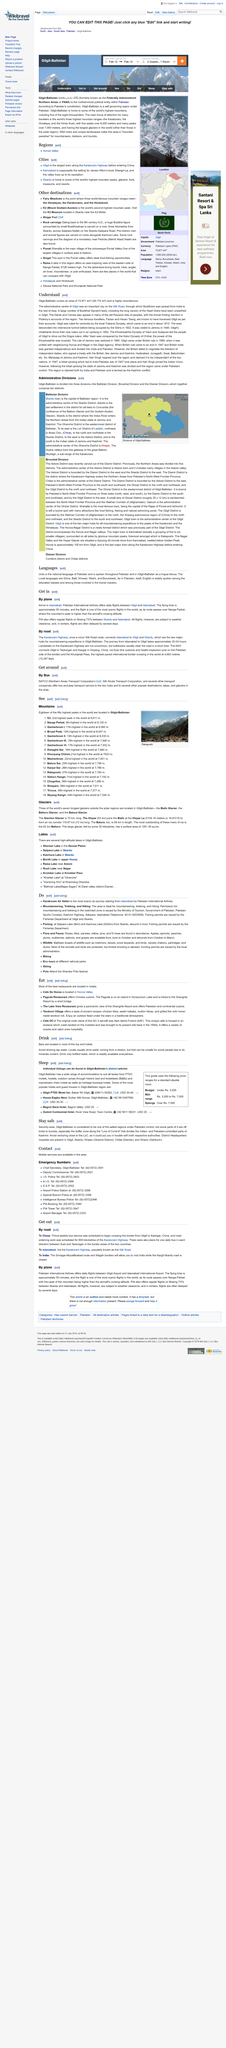Specify some key components in this picture. Gilgit-Baltistan was previously known as the Federally Administered Northern Areas (FANA). In 1860, the rule of Jammu was restored to Gilgit-Baltistan, as stated in the article "Understand. The Gilgit-Baltistan region is defined as covering an area of 72,971 square kilometres. In the year 1889, Gilgit-Baltistan was brought under British rule. The northernmost political entity in Pakistan is a self-governing region. 